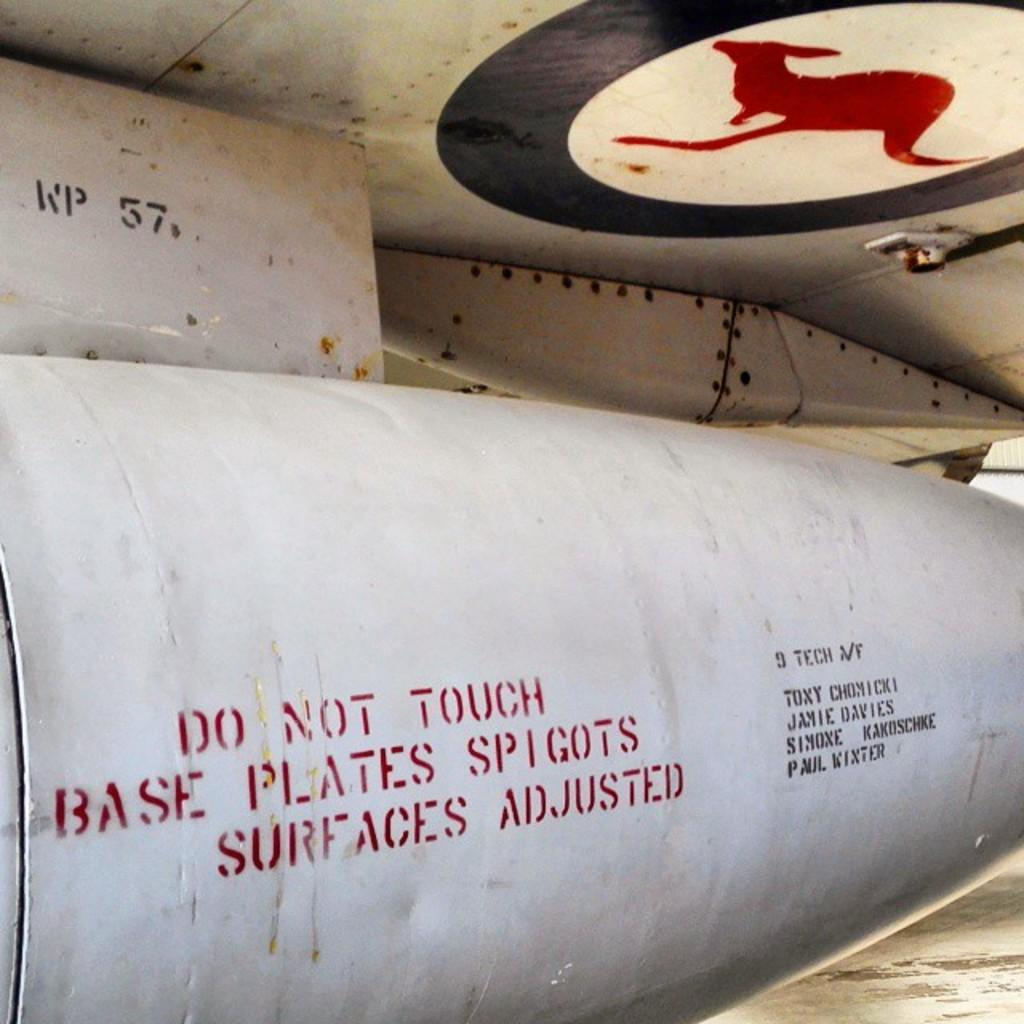<image>
Summarize the visual content of the image. Below the icon of a kangaroo, a warning message, saying to not touch the metal surface, is displayed. 